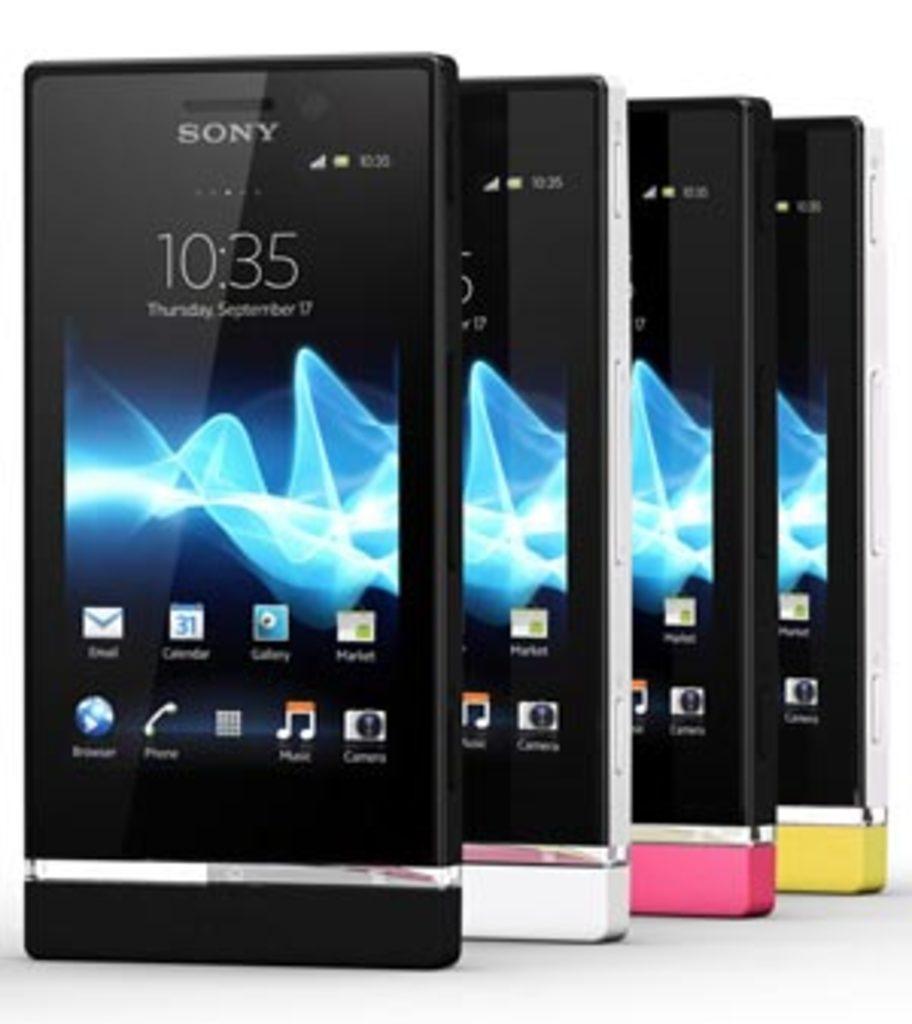What brand is that phone?
Give a very brief answer. Sony. What day of the week is displayed?
Make the answer very short. Thursday. 